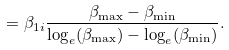Convert formula to latex. <formula><loc_0><loc_0><loc_500><loc_500>& = \beta _ { 1 i } \frac { \beta _ { \max } - \beta _ { \min } } { \log _ { e } ( \beta _ { \max } ) - \log _ { e } ( \beta _ { \min } ) } .</formula> 